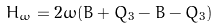<formula> <loc_0><loc_0><loc_500><loc_500>H _ { \omega } = 2 \omega ( B + Q _ { 3 } - \bar { B } - \bar { Q } _ { 3 } )</formula> 